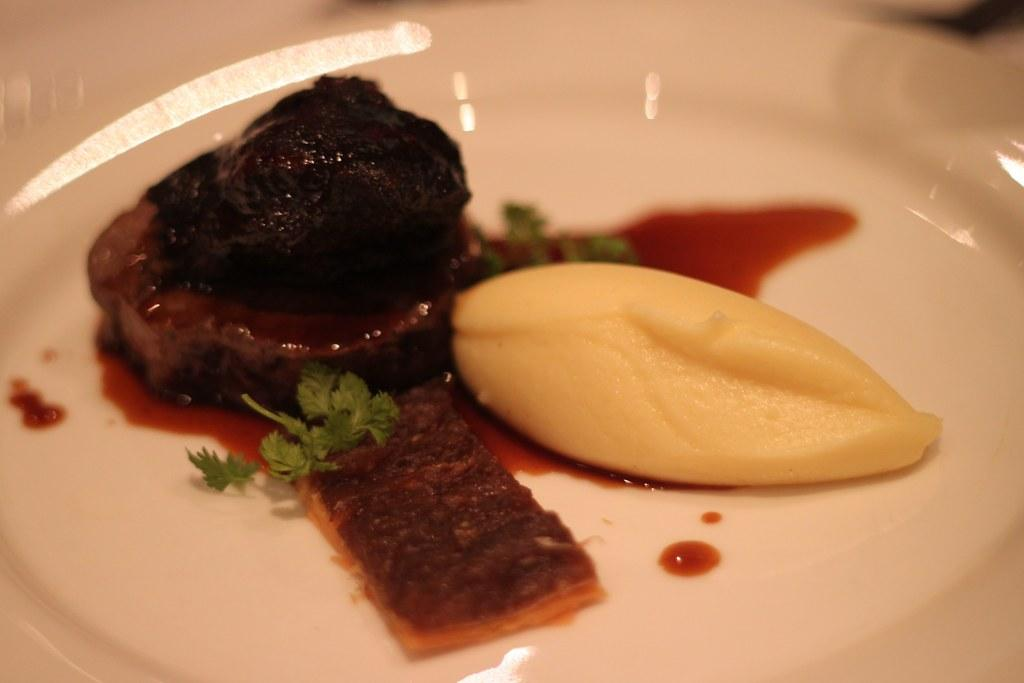What types of items can be seen in the image? There are food items in the image. What colors are the food items? The food items are in brown and cream color. What color is the plate that holds the food items? The plate is in white color. How many geese are present in the image? There are no geese present in the image; it features food items on a plate. What type of ornament is placed on the food items in the image? There is no ornament placed on the food items in the image; it only shows food items on a plate. 